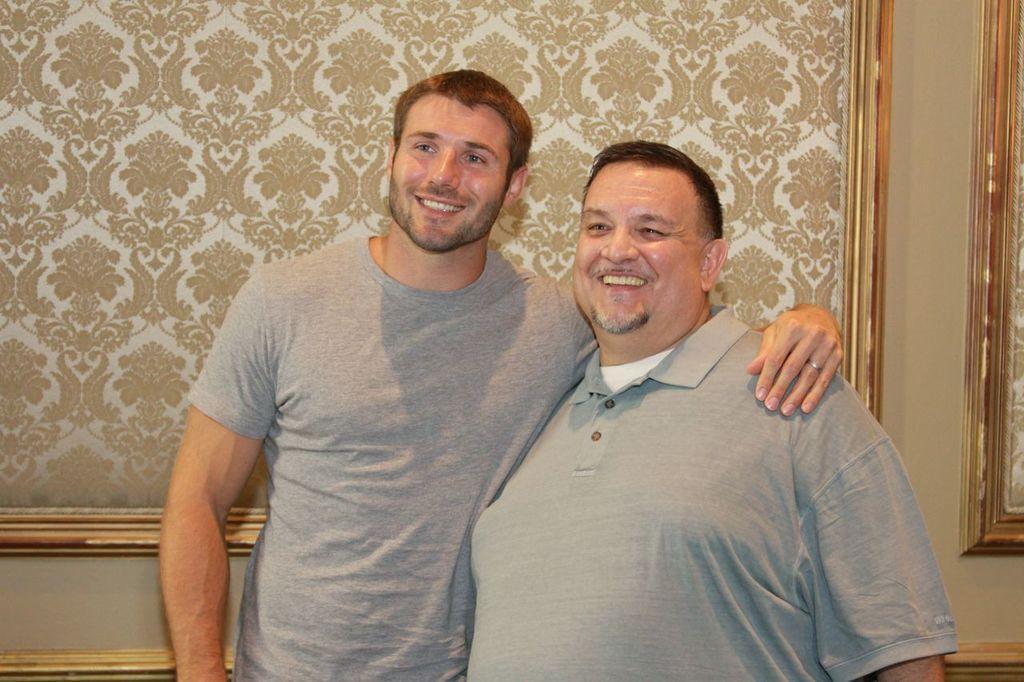In one or two sentences, can you explain what this image depicts? In this picture we can see there are two people standing and smiling and behind the people there is the designs on the wall. 